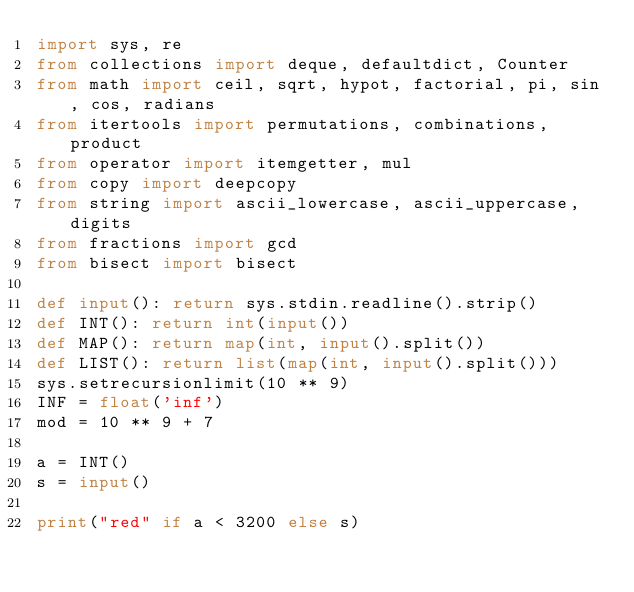<code> <loc_0><loc_0><loc_500><loc_500><_Python_>import sys, re
from collections import deque, defaultdict, Counter
from math import ceil, sqrt, hypot, factorial, pi, sin, cos, radians
from itertools import permutations, combinations, product
from operator import itemgetter, mul
from copy import deepcopy
from string import ascii_lowercase, ascii_uppercase, digits
from fractions import gcd
from bisect import bisect

def input(): return sys.stdin.readline().strip()
def INT(): return int(input())
def MAP(): return map(int, input().split())
def LIST(): return list(map(int, input().split()))
sys.setrecursionlimit(10 ** 9)
INF = float('inf')
mod = 10 ** 9 + 7

a = INT()
s = input()

print("red" if a < 3200 else s)
</code> 